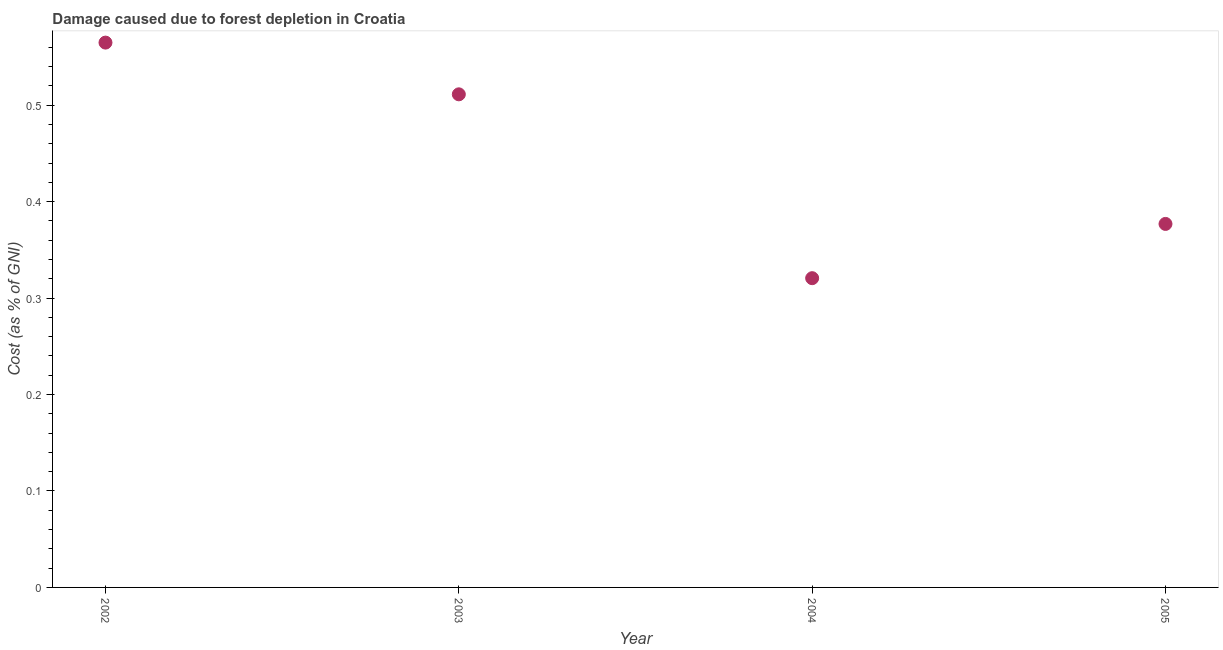What is the damage caused due to forest depletion in 2002?
Keep it short and to the point. 0.56. Across all years, what is the maximum damage caused due to forest depletion?
Keep it short and to the point. 0.56. Across all years, what is the minimum damage caused due to forest depletion?
Offer a terse response. 0.32. In which year was the damage caused due to forest depletion maximum?
Offer a terse response. 2002. In which year was the damage caused due to forest depletion minimum?
Make the answer very short. 2004. What is the sum of the damage caused due to forest depletion?
Your response must be concise. 1.77. What is the difference between the damage caused due to forest depletion in 2002 and 2004?
Provide a succinct answer. 0.24. What is the average damage caused due to forest depletion per year?
Give a very brief answer. 0.44. What is the median damage caused due to forest depletion?
Your answer should be very brief. 0.44. In how many years, is the damage caused due to forest depletion greater than 0.46 %?
Ensure brevity in your answer.  2. What is the ratio of the damage caused due to forest depletion in 2004 to that in 2005?
Your answer should be compact. 0.85. Is the difference between the damage caused due to forest depletion in 2003 and 2005 greater than the difference between any two years?
Give a very brief answer. No. What is the difference between the highest and the second highest damage caused due to forest depletion?
Provide a succinct answer. 0.05. What is the difference between the highest and the lowest damage caused due to forest depletion?
Provide a succinct answer. 0.24. Does the damage caused due to forest depletion monotonically increase over the years?
Your answer should be compact. No. How many dotlines are there?
Keep it short and to the point. 1. Does the graph contain grids?
Offer a terse response. No. What is the title of the graph?
Give a very brief answer. Damage caused due to forest depletion in Croatia. What is the label or title of the Y-axis?
Give a very brief answer. Cost (as % of GNI). What is the Cost (as % of GNI) in 2002?
Provide a short and direct response. 0.56. What is the Cost (as % of GNI) in 2003?
Your answer should be very brief. 0.51. What is the Cost (as % of GNI) in 2004?
Make the answer very short. 0.32. What is the Cost (as % of GNI) in 2005?
Provide a succinct answer. 0.38. What is the difference between the Cost (as % of GNI) in 2002 and 2003?
Provide a succinct answer. 0.05. What is the difference between the Cost (as % of GNI) in 2002 and 2004?
Keep it short and to the point. 0.24. What is the difference between the Cost (as % of GNI) in 2002 and 2005?
Provide a succinct answer. 0.19. What is the difference between the Cost (as % of GNI) in 2003 and 2004?
Provide a succinct answer. 0.19. What is the difference between the Cost (as % of GNI) in 2003 and 2005?
Your response must be concise. 0.13. What is the difference between the Cost (as % of GNI) in 2004 and 2005?
Offer a very short reply. -0.06. What is the ratio of the Cost (as % of GNI) in 2002 to that in 2003?
Your response must be concise. 1.1. What is the ratio of the Cost (as % of GNI) in 2002 to that in 2004?
Provide a succinct answer. 1.76. What is the ratio of the Cost (as % of GNI) in 2002 to that in 2005?
Make the answer very short. 1.5. What is the ratio of the Cost (as % of GNI) in 2003 to that in 2004?
Make the answer very short. 1.59. What is the ratio of the Cost (as % of GNI) in 2003 to that in 2005?
Offer a very short reply. 1.36. What is the ratio of the Cost (as % of GNI) in 2004 to that in 2005?
Your answer should be compact. 0.85. 